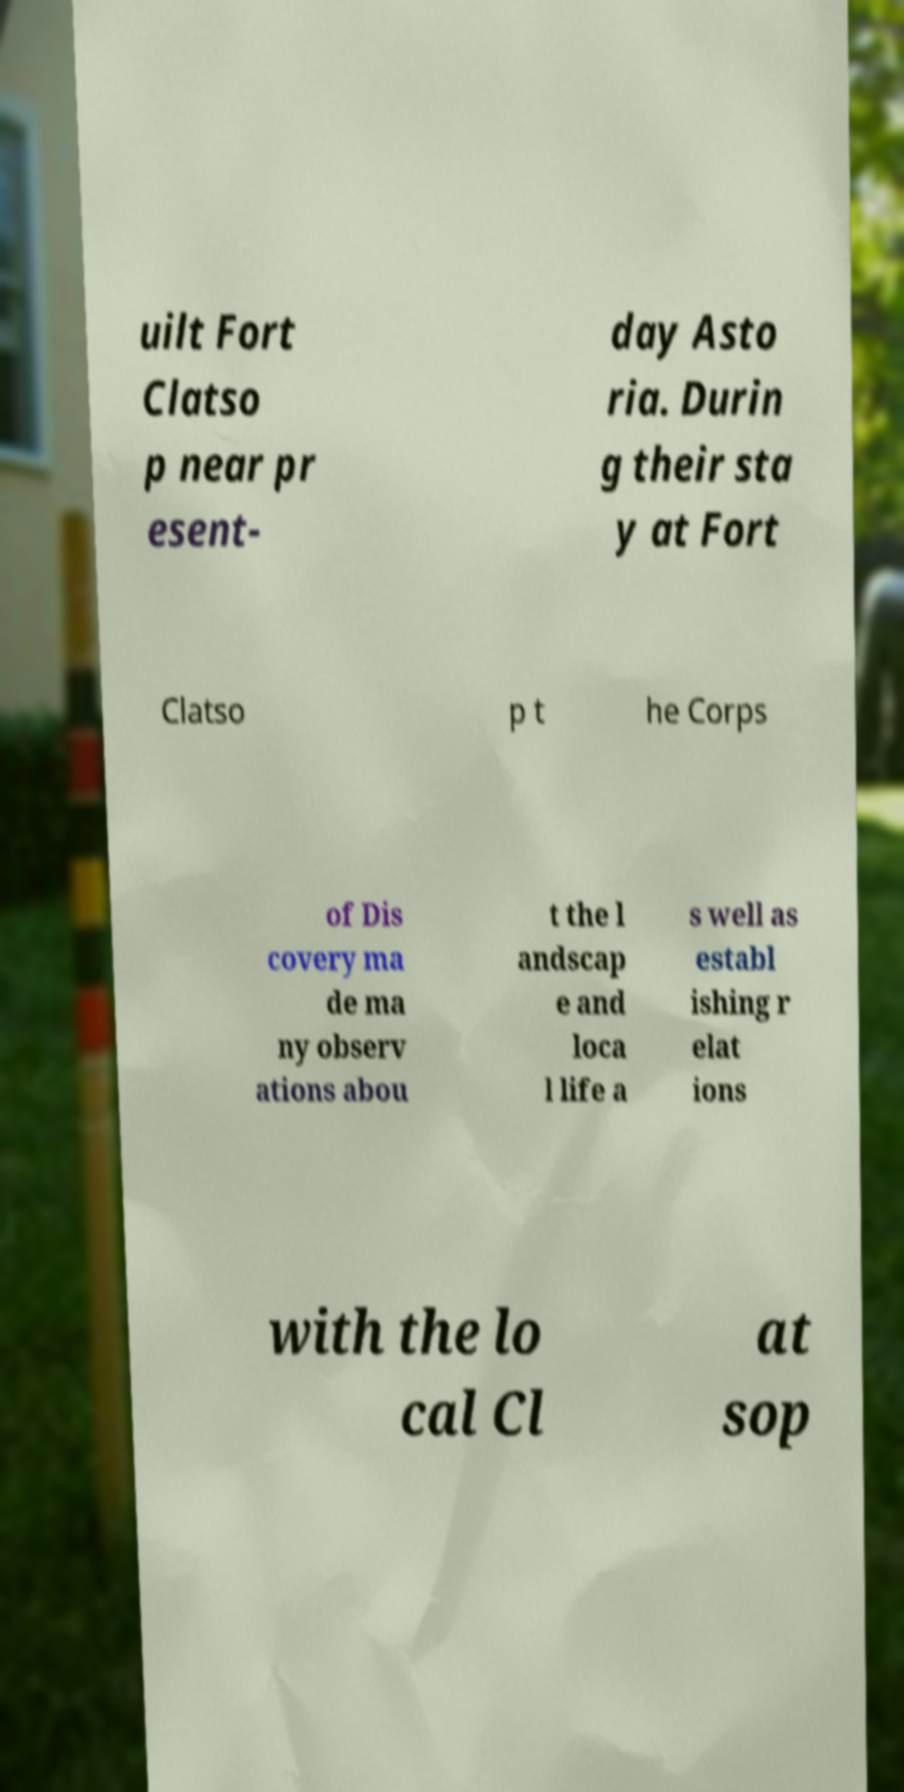Could you extract and type out the text from this image? uilt Fort Clatso p near pr esent- day Asto ria. Durin g their sta y at Fort Clatso p t he Corps of Dis covery ma de ma ny observ ations abou t the l andscap e and loca l life a s well as establ ishing r elat ions with the lo cal Cl at sop 